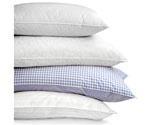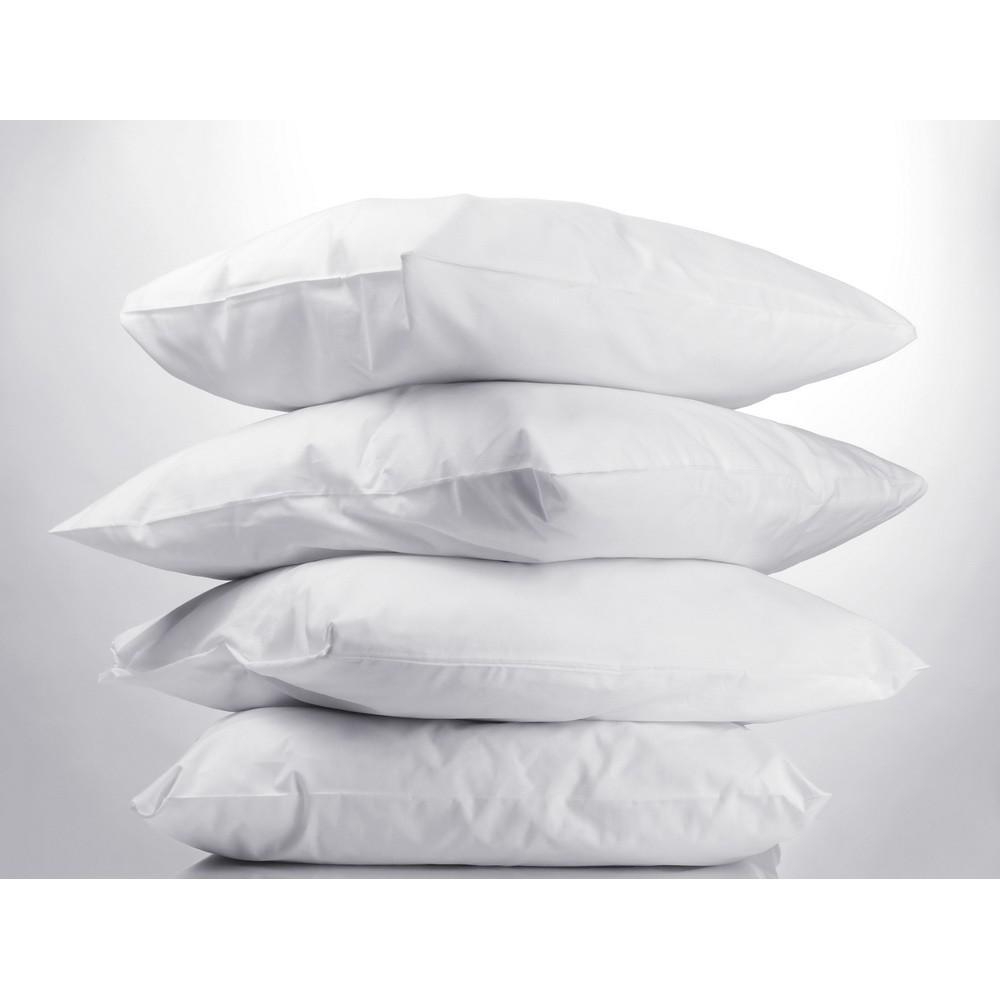The first image is the image on the left, the second image is the image on the right. Evaluate the accuracy of this statement regarding the images: "There are two stacks of four pillows.". Is it true? Answer yes or no. Yes. The first image is the image on the left, the second image is the image on the right. Analyze the images presented: Is the assertion "The left image contains a vertical stack of exactly four pillows." valid? Answer yes or no. Yes. 